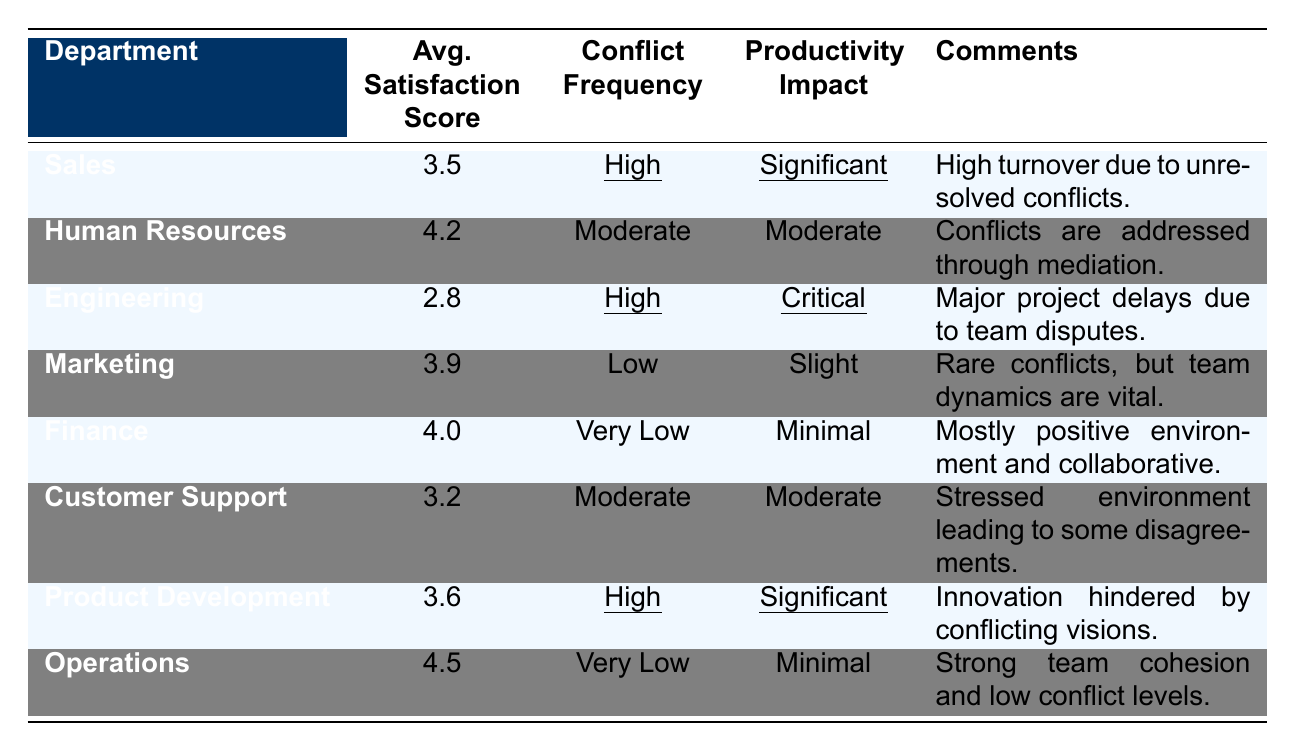What is the average satisfaction score for the Sales department? The average satisfaction score for the Sales department is directly listed in the table as 3.5.
Answer: 3.5 Which department has the highest average satisfaction score? By reviewing the average satisfaction scores in the table, the Operations department has the highest score at 4.5.
Answer: Operations How many departments are experiencing high conflict frequency? The table shows that both the Sales, Engineering, and Product Development departments have a high conflict frequency, totaling three departments.
Answer: 3 What is the productivity impact for the Engineering department? The productivity impact for the Engineering department is indicated in the table as critical.
Answer: Critical Which department reports a minimal productivity impact? The Finance and Operations departments both report a minimal productivity impact, as stated in the table.
Answer: Finance and Operations Does the Marketing department experience high conflict frequency? The table indicates that the Marketing department has a low conflict frequency, so this statement is false.
Answer: No How does the average satisfaction score relate to conflict frequency for departments labeled as high conflict? The average satisfaction scores for the high conflict departments (Sales, Engineering, and Product Development) are 3.5, 2.8, and 3.6 respectively, indicating a trend of lower satisfaction in relation to high conflict.
Answer: Lower satisfaction What is the difference in average satisfaction scores between the highest and lowest rated departments? The highest-rated department, Operations, has a score of 4.5 and the lowest-rated department, Engineering, has a score of 2.8. The difference is 4.5 - 2.8 = 1.7.
Answer: 1.7 Which department had comments indicating a strong team cohesion and low conflict levels? The Operations department's comments indicate strong team cohesion and low conflict levels.
Answer: Operations What is the average satisfaction score for departments with very low conflict frequency? The Finance (4.0) and Operations (4.5) departments have very low conflict frequency, so the average score is (4.0 + 4.5) / 2 = 4.25.
Answer: 4.25 